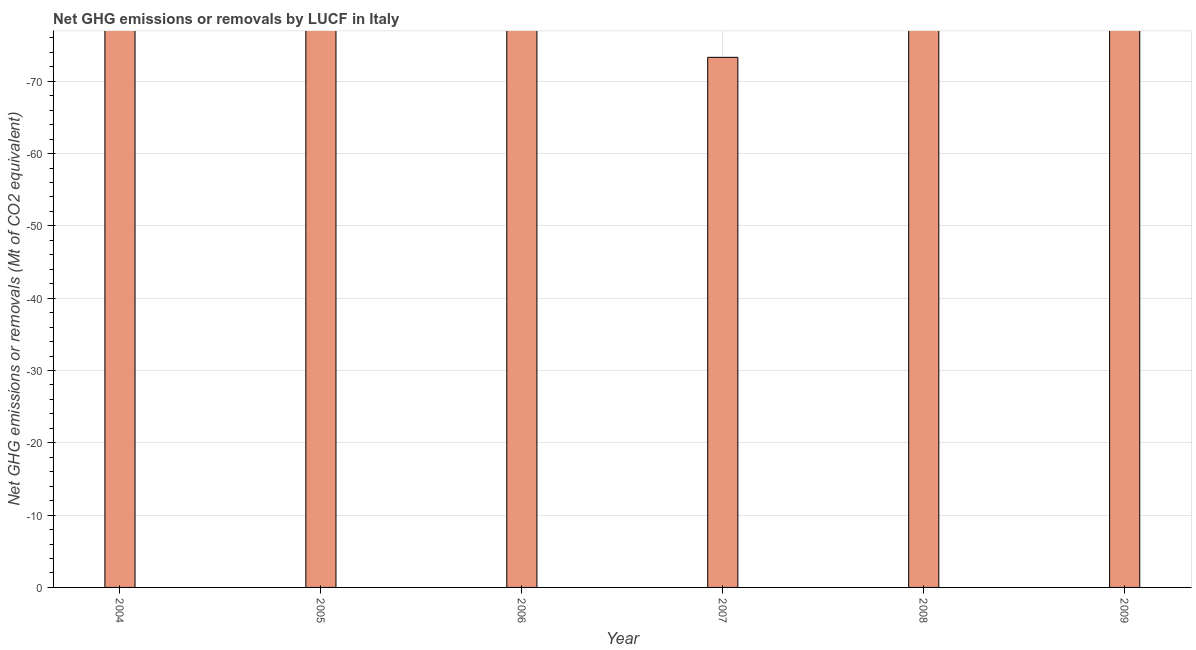Does the graph contain any zero values?
Ensure brevity in your answer.  Yes. What is the title of the graph?
Make the answer very short. Net GHG emissions or removals by LUCF in Italy. What is the label or title of the X-axis?
Provide a short and direct response. Year. What is the label or title of the Y-axis?
Keep it short and to the point. Net GHG emissions or removals (Mt of CO2 equivalent). Across all years, what is the minimum ghg net emissions or removals?
Provide a succinct answer. 0. In how many years, is the ghg net emissions or removals greater than the average ghg net emissions or removals taken over all years?
Ensure brevity in your answer.  0. How many years are there in the graph?
Give a very brief answer. 6. Are the values on the major ticks of Y-axis written in scientific E-notation?
Make the answer very short. No. What is the Net GHG emissions or removals (Mt of CO2 equivalent) in 2004?
Make the answer very short. 0. What is the Net GHG emissions or removals (Mt of CO2 equivalent) in 2006?
Your answer should be very brief. 0. What is the Net GHG emissions or removals (Mt of CO2 equivalent) of 2008?
Make the answer very short. 0. What is the Net GHG emissions or removals (Mt of CO2 equivalent) of 2009?
Offer a very short reply. 0. 